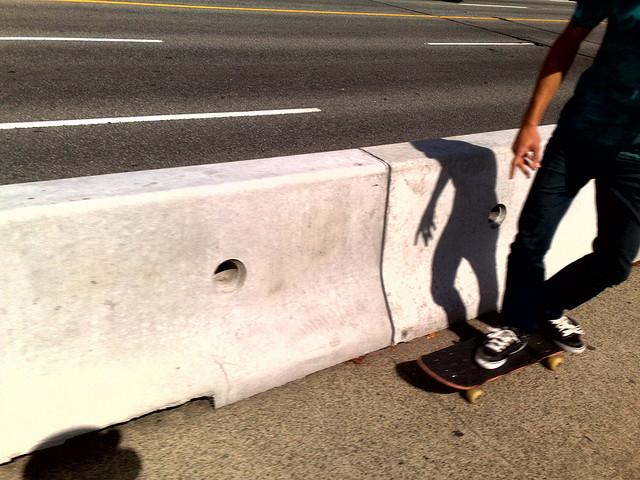Can you see this person's head?
Give a very brief answer. No. What is this person riding?
Concise answer only. Skateboard. Are there cars on the road?
Give a very brief answer. No. 